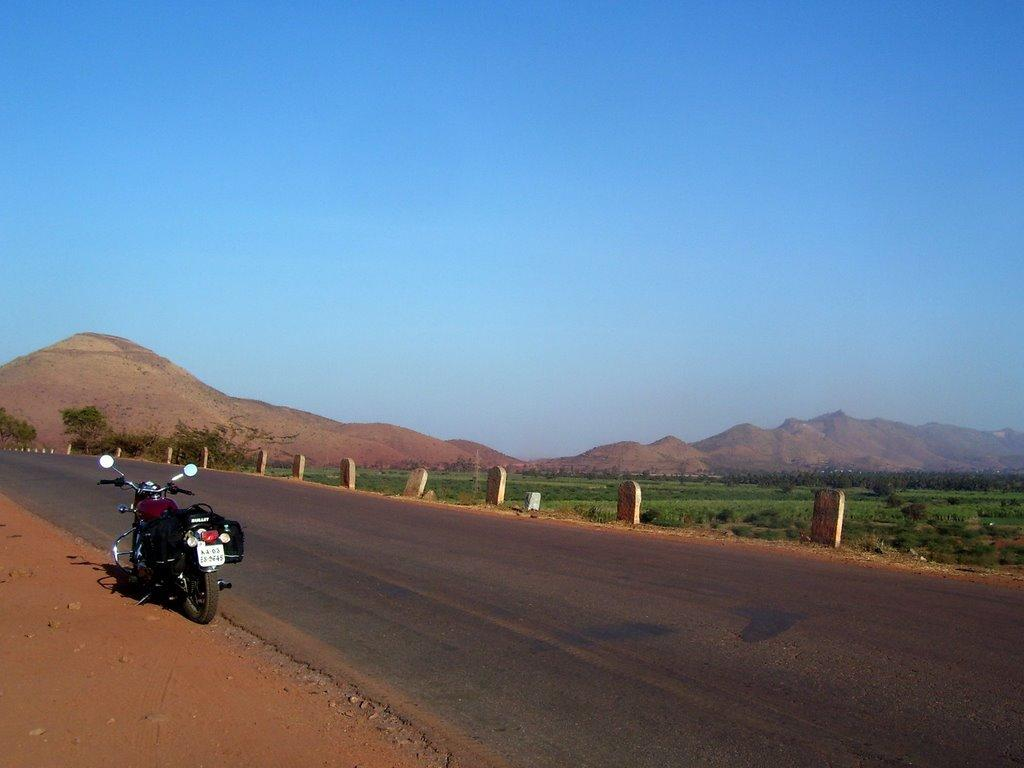What type of vehicle is parked on the side of the road in the image? There is a motorbike parked on the side of the road in the image. What type of markers can be seen in the image? There are milestones visible in the image. What type of landscape is visible in the image? There is farmland and trees visible in the image. What can be seen in the background of the image? There are hills and a blue sky visible in the background of the image. What type of hope can be seen in the image? There is no hope present in the image; it is a photograph of a motorbike parked on the side of the road with milestones, farmland, trees, hills, and a blue sky in the background. 